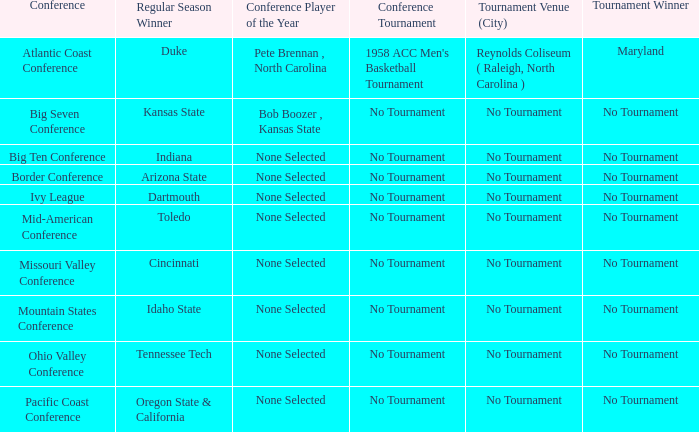In the season when idaho state triumphed in the regular season, which team came out on top in the tournament? No Tournament. 